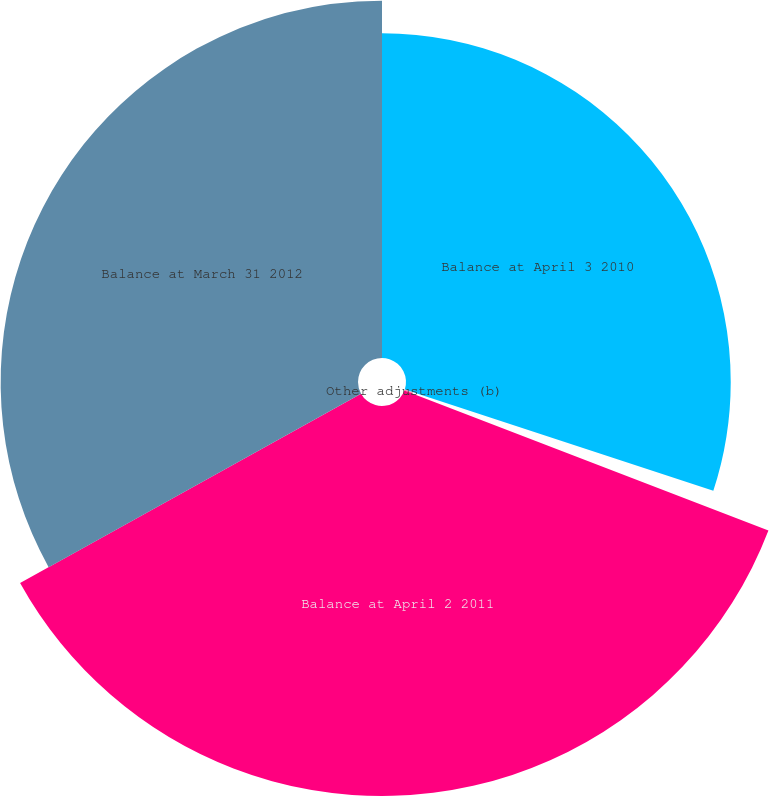<chart> <loc_0><loc_0><loc_500><loc_500><pie_chart><fcel>Balance at April 3 2010<fcel>Other adjustments (b)<fcel>Balance at April 2 2011<fcel>Balance at March 31 2012<nl><fcel>30.05%<fcel>0.79%<fcel>36.09%<fcel>33.07%<nl></chart> 